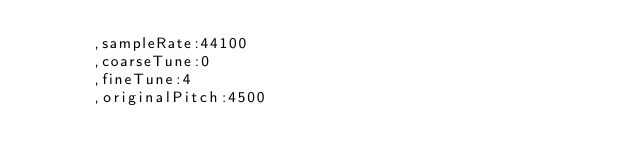<code> <loc_0><loc_0><loc_500><loc_500><_JavaScript_>			,sampleRate:44100
			,coarseTune:0
			,fineTune:4
			,originalPitch:4500</code> 